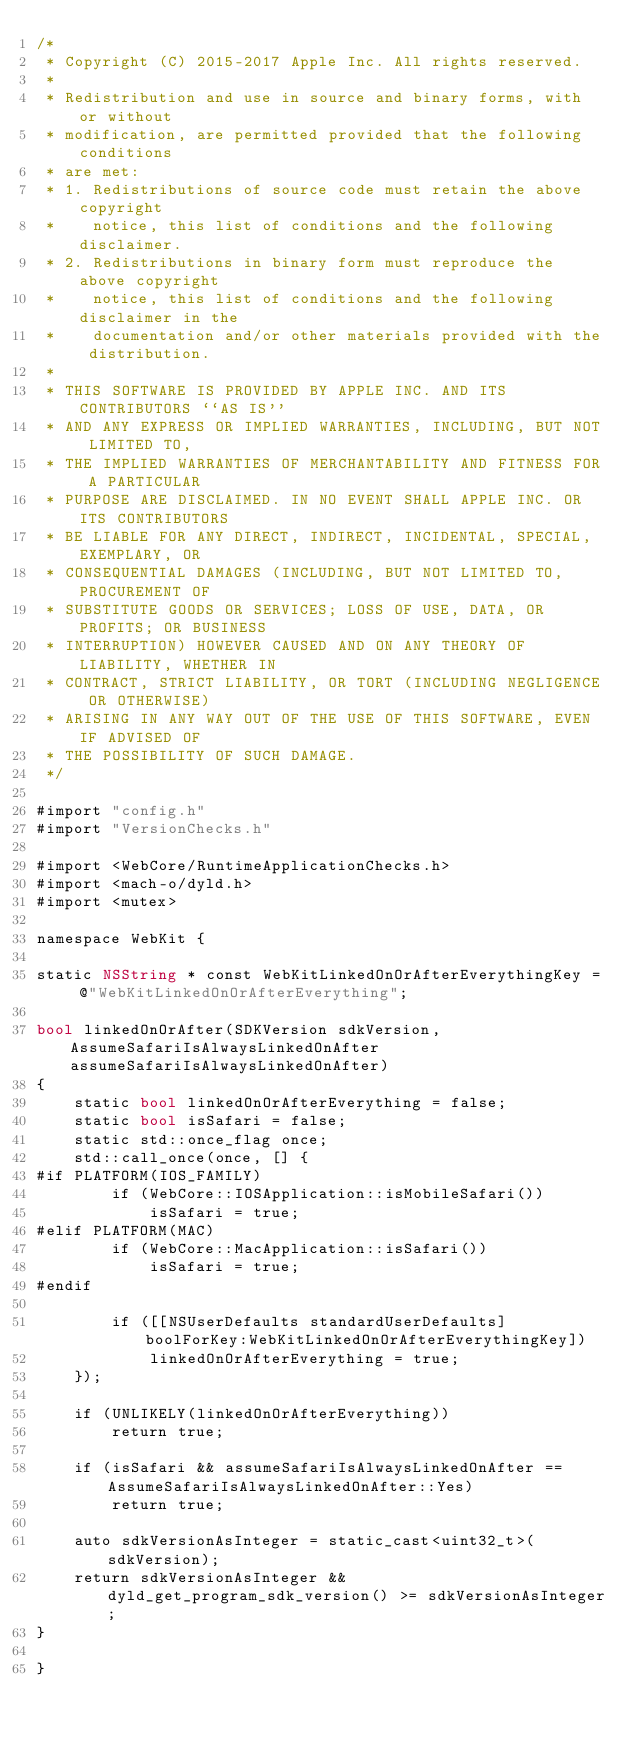<code> <loc_0><loc_0><loc_500><loc_500><_ObjectiveC_>/*
 * Copyright (C) 2015-2017 Apple Inc. All rights reserved.
 *
 * Redistribution and use in source and binary forms, with or without
 * modification, are permitted provided that the following conditions
 * are met:
 * 1. Redistributions of source code must retain the above copyright
 *    notice, this list of conditions and the following disclaimer.
 * 2. Redistributions in binary form must reproduce the above copyright
 *    notice, this list of conditions and the following disclaimer in the
 *    documentation and/or other materials provided with the distribution.
 *
 * THIS SOFTWARE IS PROVIDED BY APPLE INC. AND ITS CONTRIBUTORS ``AS IS''
 * AND ANY EXPRESS OR IMPLIED WARRANTIES, INCLUDING, BUT NOT LIMITED TO,
 * THE IMPLIED WARRANTIES OF MERCHANTABILITY AND FITNESS FOR A PARTICULAR
 * PURPOSE ARE DISCLAIMED. IN NO EVENT SHALL APPLE INC. OR ITS CONTRIBUTORS
 * BE LIABLE FOR ANY DIRECT, INDIRECT, INCIDENTAL, SPECIAL, EXEMPLARY, OR
 * CONSEQUENTIAL DAMAGES (INCLUDING, BUT NOT LIMITED TO, PROCUREMENT OF
 * SUBSTITUTE GOODS OR SERVICES; LOSS OF USE, DATA, OR PROFITS; OR BUSINESS
 * INTERRUPTION) HOWEVER CAUSED AND ON ANY THEORY OF LIABILITY, WHETHER IN
 * CONTRACT, STRICT LIABILITY, OR TORT (INCLUDING NEGLIGENCE OR OTHERWISE)
 * ARISING IN ANY WAY OUT OF THE USE OF THIS SOFTWARE, EVEN IF ADVISED OF
 * THE POSSIBILITY OF SUCH DAMAGE.
 */

#import "config.h"
#import "VersionChecks.h"

#import <WebCore/RuntimeApplicationChecks.h>
#import <mach-o/dyld.h>
#import <mutex>

namespace WebKit {

static NSString * const WebKitLinkedOnOrAfterEverythingKey = @"WebKitLinkedOnOrAfterEverything";

bool linkedOnOrAfter(SDKVersion sdkVersion, AssumeSafariIsAlwaysLinkedOnAfter assumeSafariIsAlwaysLinkedOnAfter)
{
    static bool linkedOnOrAfterEverything = false;
    static bool isSafari = false;
    static std::once_flag once;
    std::call_once(once, [] {
#if PLATFORM(IOS_FAMILY)
        if (WebCore::IOSApplication::isMobileSafari())
            isSafari = true;
#elif PLATFORM(MAC)
        if (WebCore::MacApplication::isSafari())
            isSafari = true;
#endif

        if ([[NSUserDefaults standardUserDefaults] boolForKey:WebKitLinkedOnOrAfterEverythingKey])
            linkedOnOrAfterEverything = true;
    });

    if (UNLIKELY(linkedOnOrAfterEverything))
        return true;

    if (isSafari && assumeSafariIsAlwaysLinkedOnAfter == AssumeSafariIsAlwaysLinkedOnAfter::Yes)
        return true;

    auto sdkVersionAsInteger = static_cast<uint32_t>(sdkVersion);
    return sdkVersionAsInteger && dyld_get_program_sdk_version() >= sdkVersionAsInteger;
}

}
</code> 